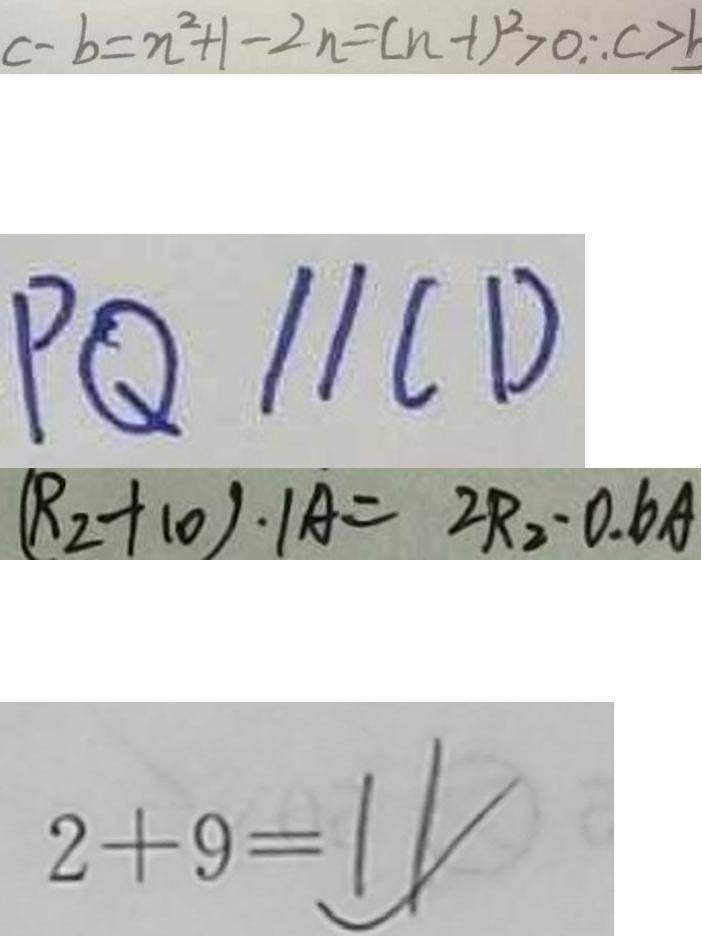<formula> <loc_0><loc_0><loc_500><loc_500>c - b = n ^ { 2 } + 1 - 2 n = ( n - 1 ) ^ { 2 } > 0 \therefore c > b 
 P Q / / C D 
 ( R _ { 2 } + 1 0 ) \cdot 1 A = 2 R _ { 2 } \cdot 0 . 6 A 
 2 + 9 = 1 1</formula> 